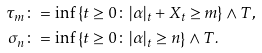Convert formula to latex. <formula><loc_0><loc_0><loc_500><loc_500>\tau _ { m } & \colon = \inf \left \{ t \geq 0 \colon | \alpha | _ { t } + X _ { t } \geq m \right \} \wedge T , \\ \sigma _ { n } & \colon = \inf \left \{ t \geq 0 \colon | \alpha | _ { t } \geq n \right \} \wedge T .</formula> 